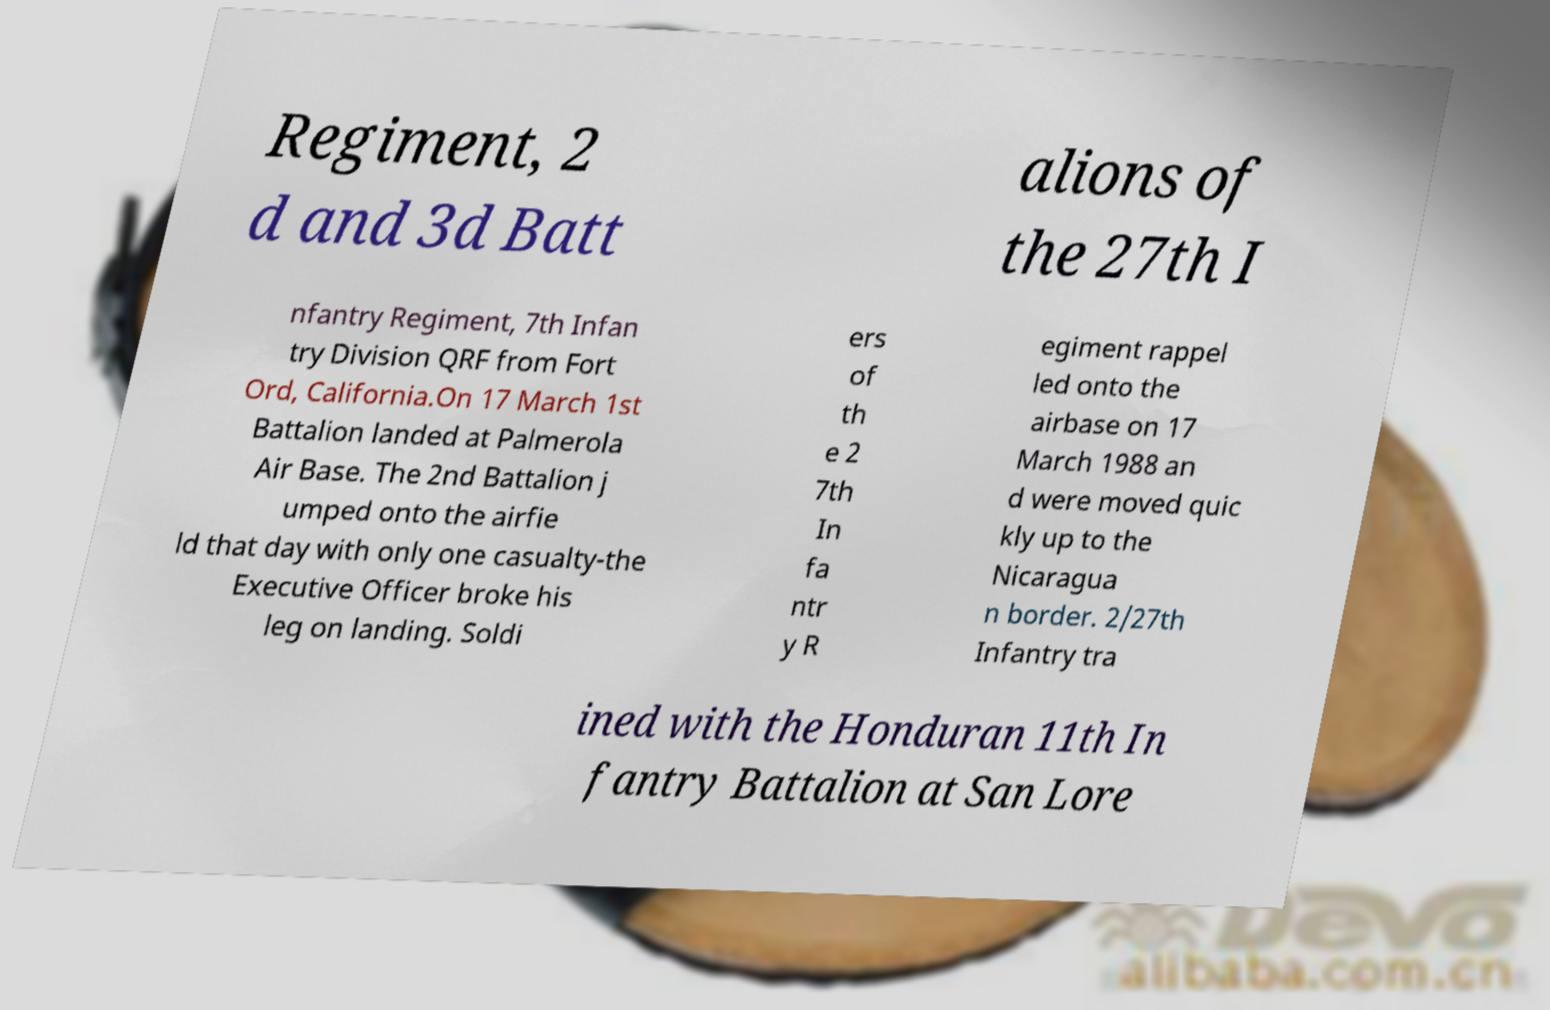Please read and relay the text visible in this image. What does it say? Regiment, 2 d and 3d Batt alions of the 27th I nfantry Regiment, 7th Infan try Division QRF from Fort Ord, California.On 17 March 1st Battalion landed at Palmerola Air Base. The 2nd Battalion j umped onto the airfie ld that day with only one casualty-the Executive Officer broke his leg on landing. Soldi ers of th e 2 7th In fa ntr y R egiment rappel led onto the airbase on 17 March 1988 an d were moved quic kly up to the Nicaragua n border. 2/27th Infantry tra ined with the Honduran 11th In fantry Battalion at San Lore 